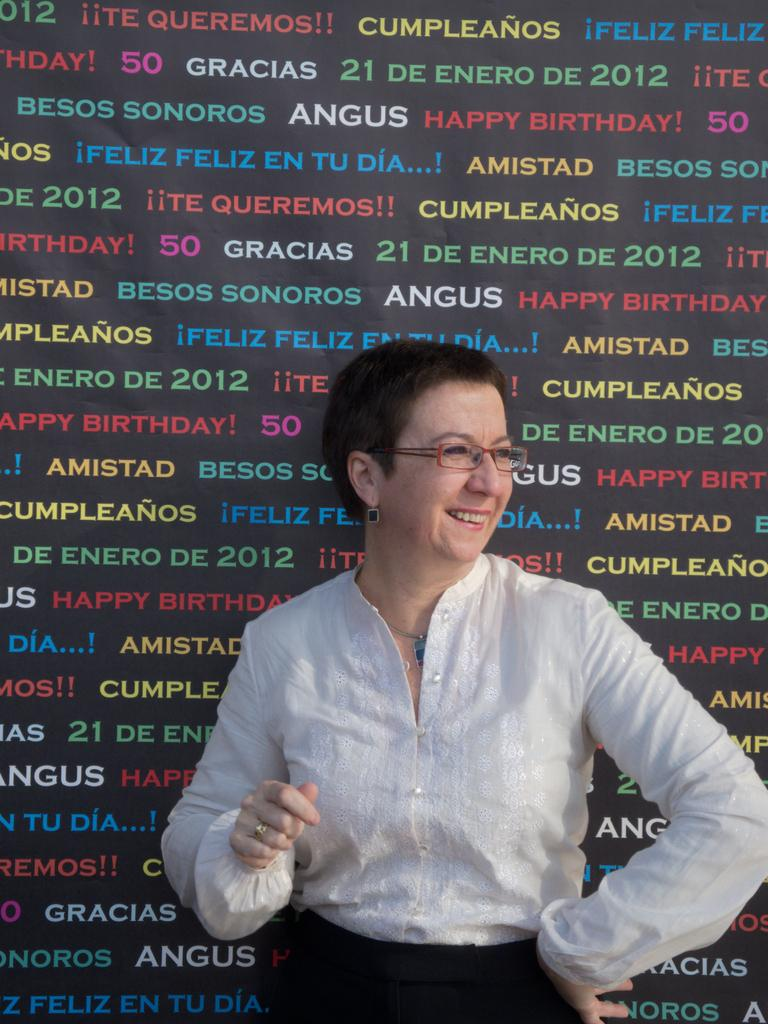Who is the main subject in the image? There is a woman in the image. What is the woman wearing? The woman is wearing a white top. What can be seen in the background of the image? There is a banner in the background of the image. What is written on the banner? There is text on the banner. How many rings can be seen on the woman's finger in the image? There is no mention of rings or fingers in the image, so it cannot be determined if any rings are present. 